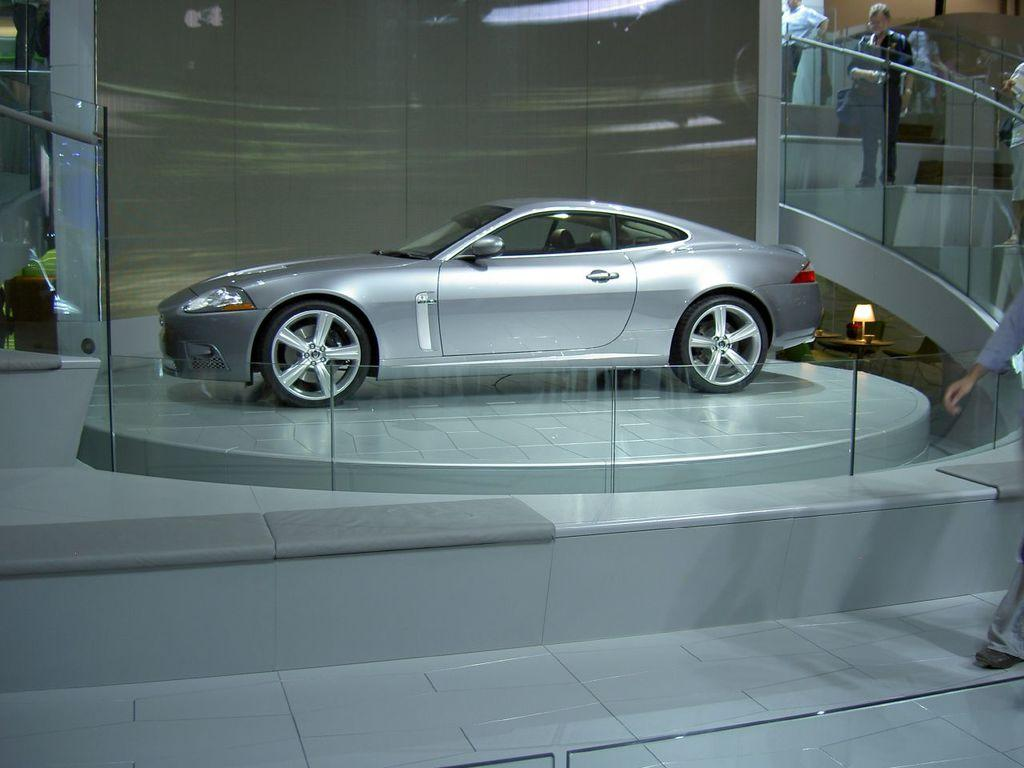What is located on the floor in the foreground of the image? There is a car on the floor in the foreground. What can be seen in the foreground besides the car? There is a fence and a group of people on the steps in the foreground. What is visible in the background of the image? There is a wall in the background. Can you make any assumptions about the setting of the image? The image may have been taken in a showroom, based on the presence of a car and the possibility of a controlled environment. What type of tent can be seen in the image? There is no tent present in the image. What message of peace is being conveyed by the people in the image? There is no indication of a message of peace being conveyed by the people in the image. 